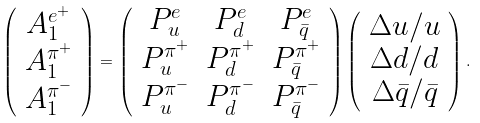Convert formula to latex. <formula><loc_0><loc_0><loc_500><loc_500>\left ( \begin{array} { c } A _ { 1 } ^ { e ^ { + } } \\ A _ { 1 } ^ { \pi ^ { + } } \\ A _ { 1 } ^ { \pi ^ { - } } \end{array} \right ) = \left ( \begin{array} { c c c } P _ { u } ^ { e } & P _ { d } ^ { e } & P _ { \bar { q } } ^ { e } \\ P _ { u } ^ { \pi ^ { + } } & P _ { d } ^ { \pi ^ { + } } & P _ { \bar { q } } ^ { \pi ^ { + } } \\ P _ { u } ^ { \pi ^ { - } } & P _ { d } ^ { \pi ^ { - } } & P _ { \bar { q } } ^ { \pi ^ { - } } \end{array} \right ) \left ( \begin{array} { c } \Delta u / u \\ \Delta d / d \\ \Delta \bar { q } / \bar { q } \end{array} \right ) .</formula> 